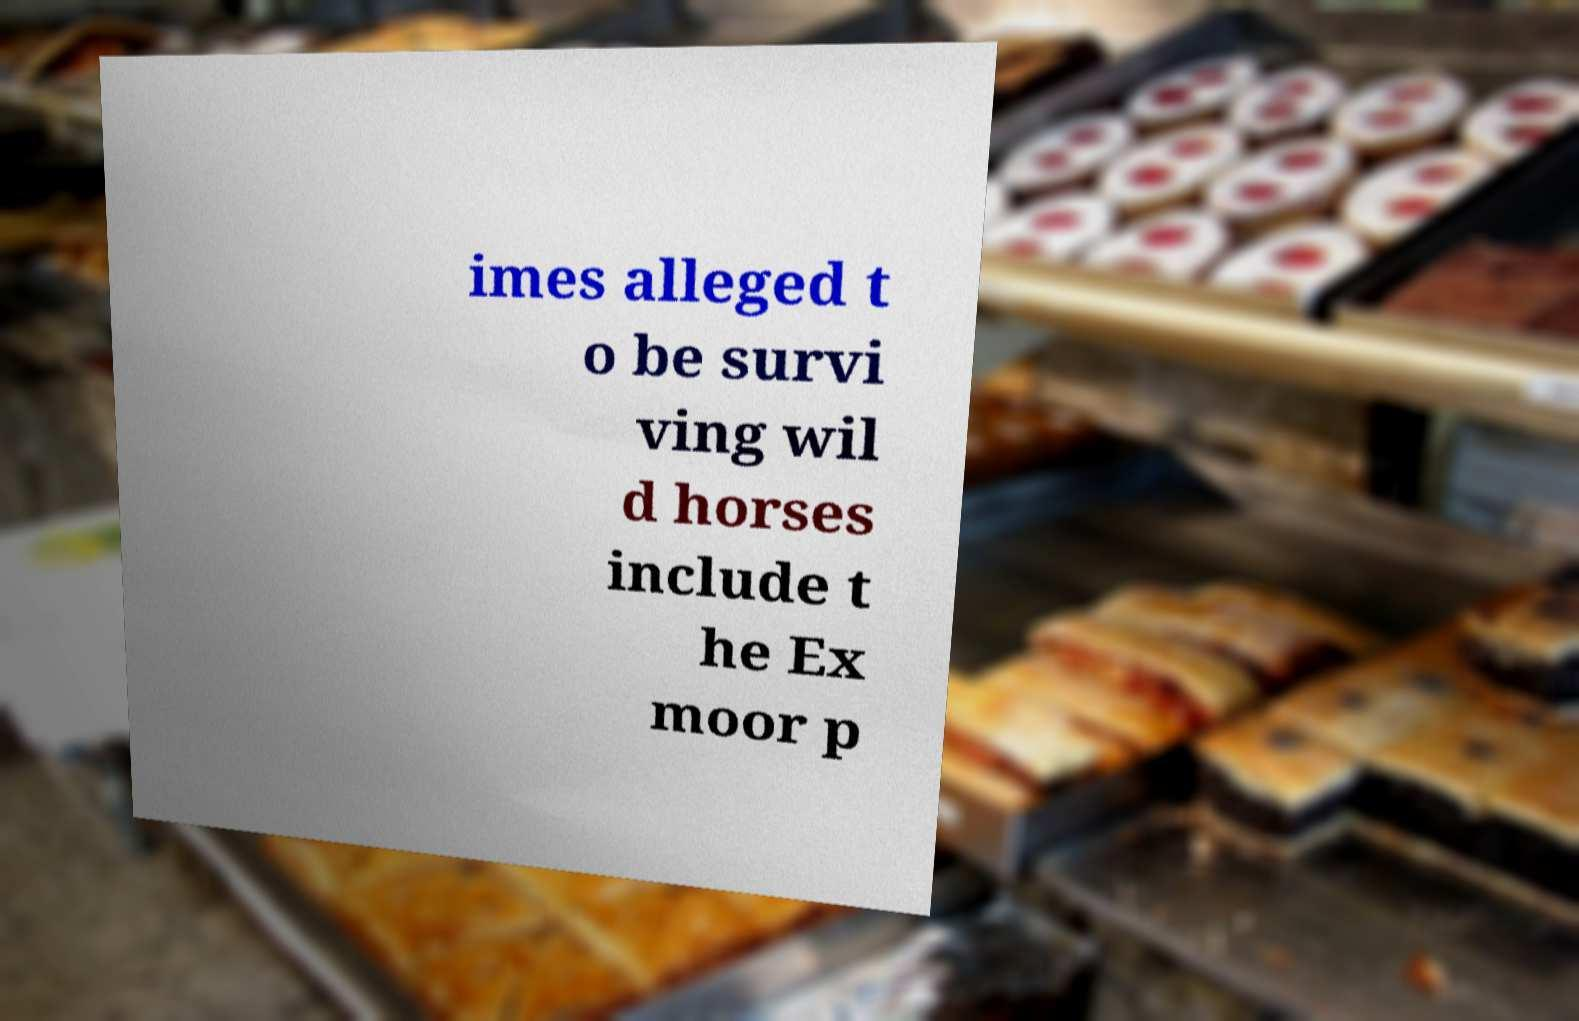What messages or text are displayed in this image? I need them in a readable, typed format. imes alleged t o be survi ving wil d horses include t he Ex moor p 